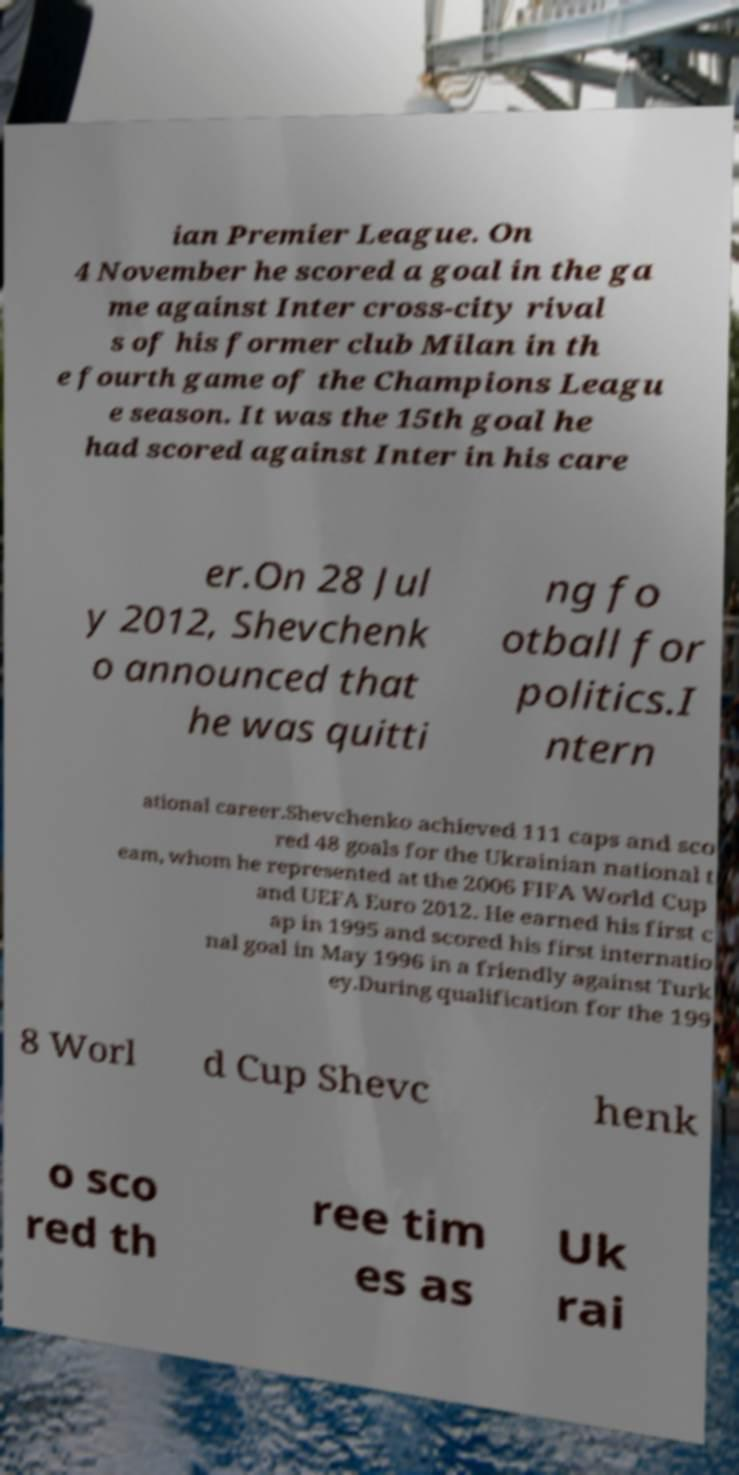Can you accurately transcribe the text from the provided image for me? ian Premier League. On 4 November he scored a goal in the ga me against Inter cross-city rival s of his former club Milan in th e fourth game of the Champions Leagu e season. It was the 15th goal he had scored against Inter in his care er.On 28 Jul y 2012, Shevchenk o announced that he was quitti ng fo otball for politics.I ntern ational career.Shevchenko achieved 111 caps and sco red 48 goals for the Ukrainian national t eam, whom he represented at the 2006 FIFA World Cup and UEFA Euro 2012. He earned his first c ap in 1995 and scored his first internatio nal goal in May 1996 in a friendly against Turk ey.During qualification for the 199 8 Worl d Cup Shevc henk o sco red th ree tim es as Uk rai 